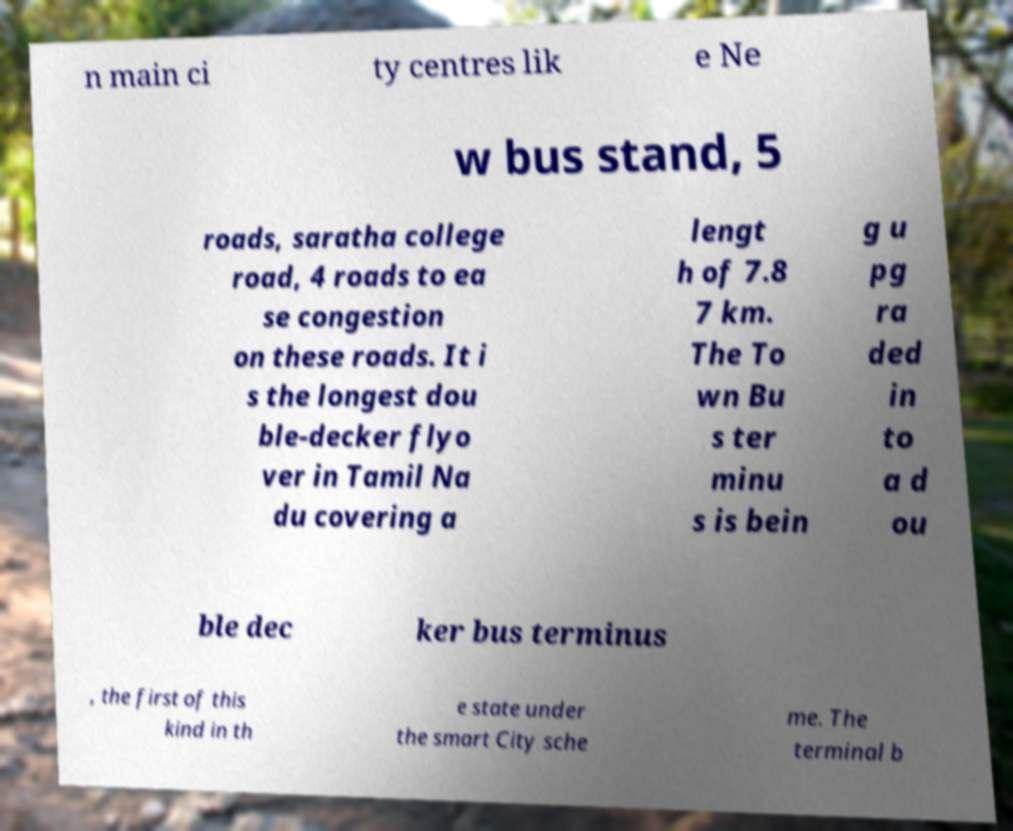Could you extract and type out the text from this image? n main ci ty centres lik e Ne w bus stand, 5 roads, saratha college road, 4 roads to ea se congestion on these roads. It i s the longest dou ble-decker flyo ver in Tamil Na du covering a lengt h of 7.8 7 km. The To wn Bu s ter minu s is bein g u pg ra ded in to a d ou ble dec ker bus terminus , the first of this kind in th e state under the smart City sche me. The terminal b 